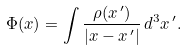<formula> <loc_0><loc_0><loc_500><loc_500>\Phi ( { x } ) = \int \frac { \rho ( { x ^ { \, \prime } } ) } { | { x } - { x } ^ { \, \prime } | } \, d ^ { 3 } x ^ { \, \prime } .</formula> 